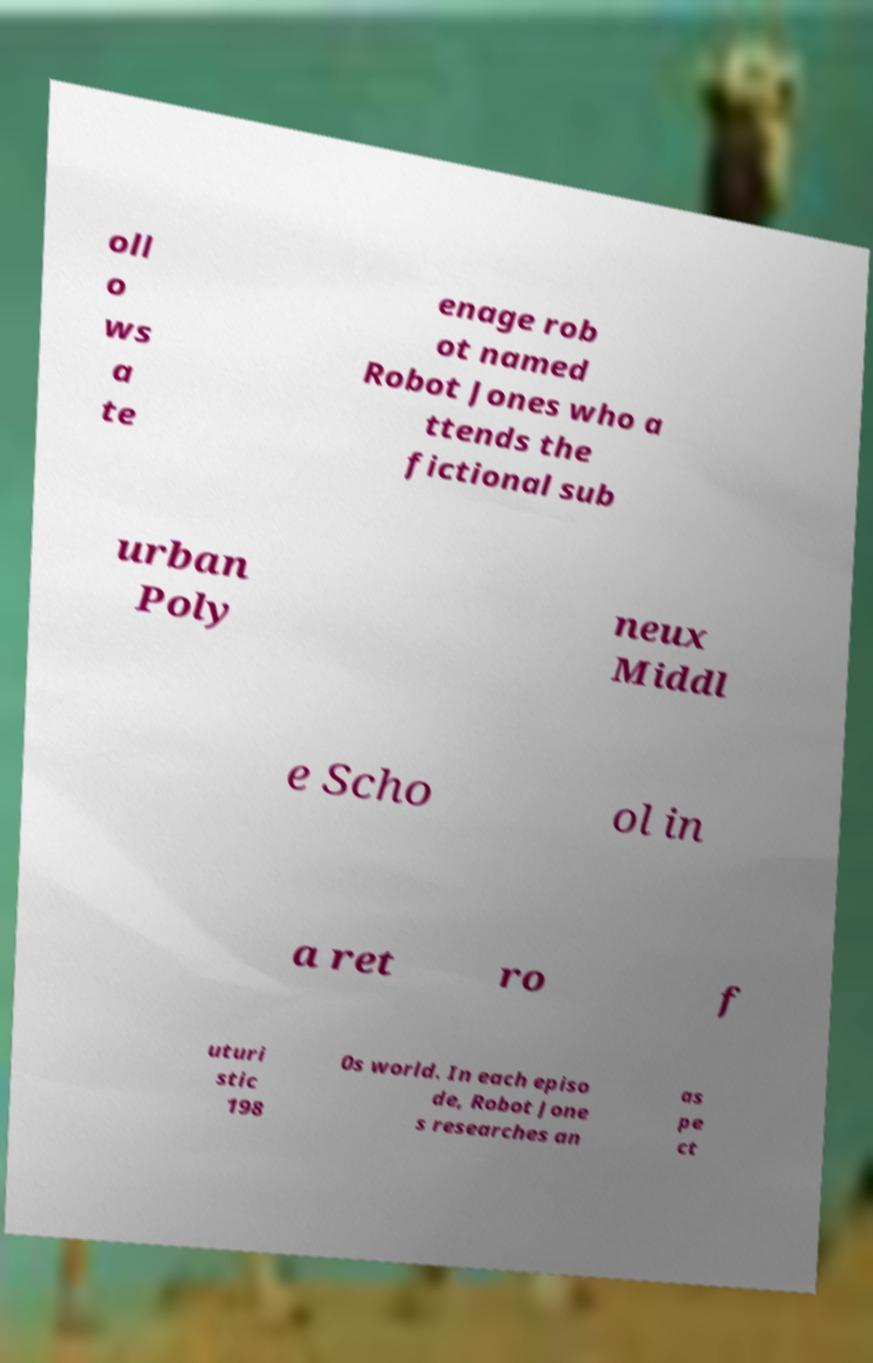Could you assist in decoding the text presented in this image and type it out clearly? oll o ws a te enage rob ot named Robot Jones who a ttends the fictional sub urban Poly neux Middl e Scho ol in a ret ro f uturi stic 198 0s world. In each episo de, Robot Jone s researches an as pe ct 